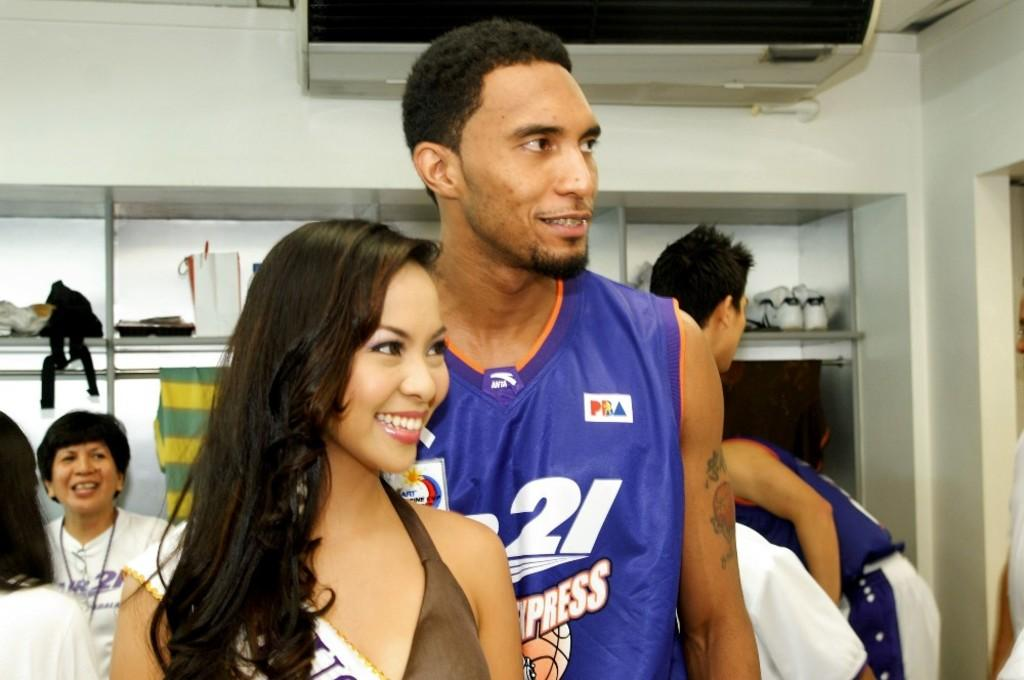Provide a one-sentence caption for the provided image. Basketball player number 21 stands behind a good looking woman. 